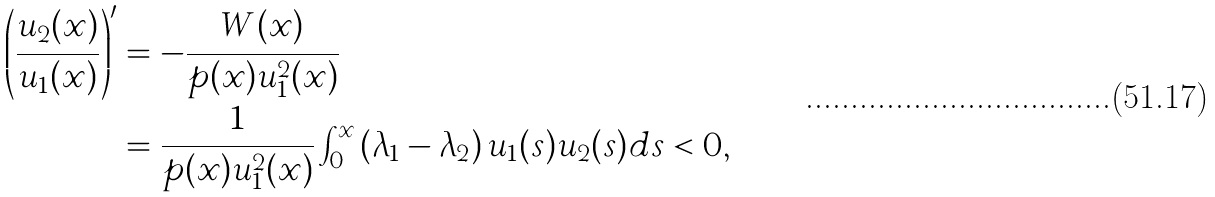Convert formula to latex. <formula><loc_0><loc_0><loc_500><loc_500>\left ( \frac { u _ { 2 } ( x ) } { u _ { 1 } ( x ) } \right ) ^ { \prime } & = - \frac { W ( x ) } { p ( x ) u _ { 1 } ^ { 2 } ( x ) } \\ & = \frac { 1 } { p ( x ) u _ { 1 } ^ { 2 } ( x ) } \int _ { 0 } ^ { x } \left ( \lambda _ { 1 } - \lambda _ { 2 } \right ) u _ { 1 } ( s ) u _ { 2 } ( s ) d s < 0 ,</formula> 